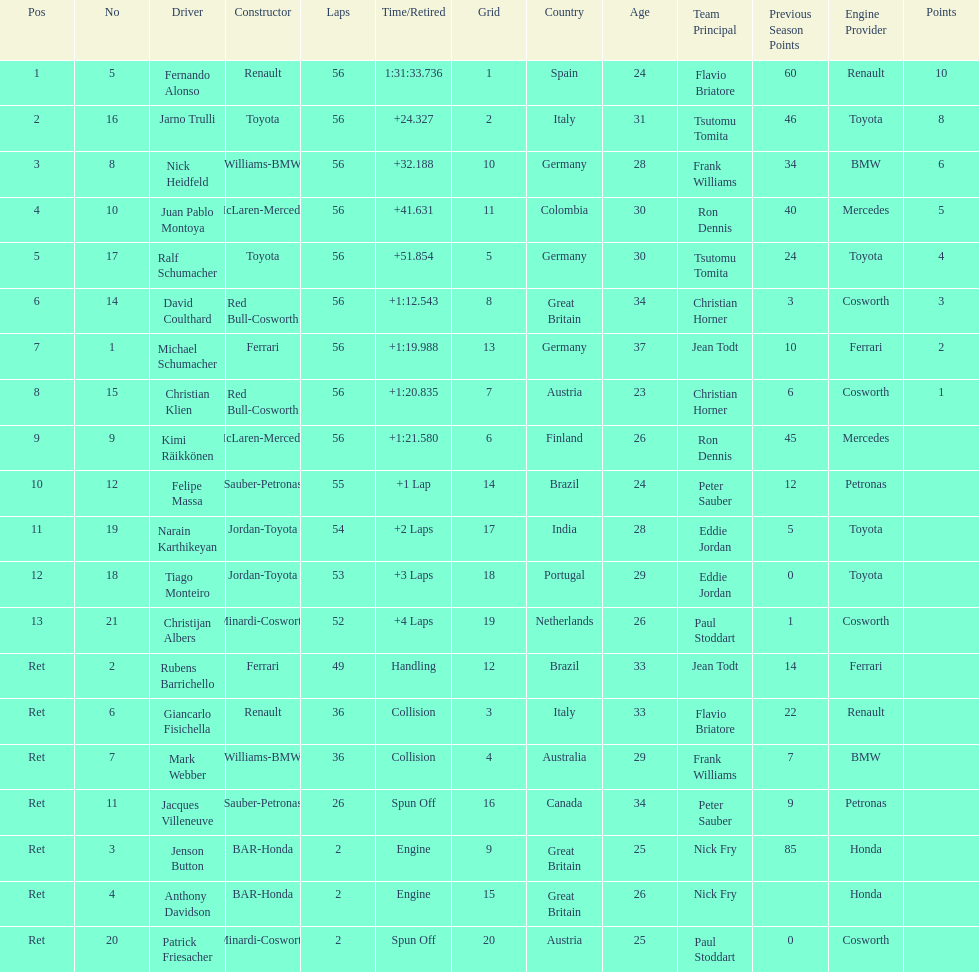How many drivers were retired before the race could end? 7. 